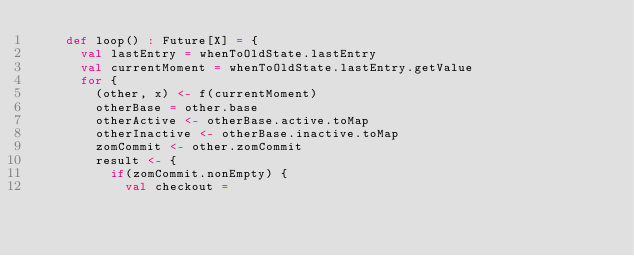Convert code to text. <code><loc_0><loc_0><loc_500><loc_500><_Scala_>    def loop() : Future[X] = {
      val lastEntry = whenToOldState.lastEntry
      val currentMoment = whenToOldState.lastEntry.getValue
      for {
        (other, x) <- f(currentMoment)
        otherBase = other.base
        otherActive <- otherBase.active.toMap
        otherInactive <- otherBase.inactive.toMap
        zomCommit <- other.zomCommit
        result <- {
          if(zomCommit.nonEmpty) {
            val checkout =</code> 